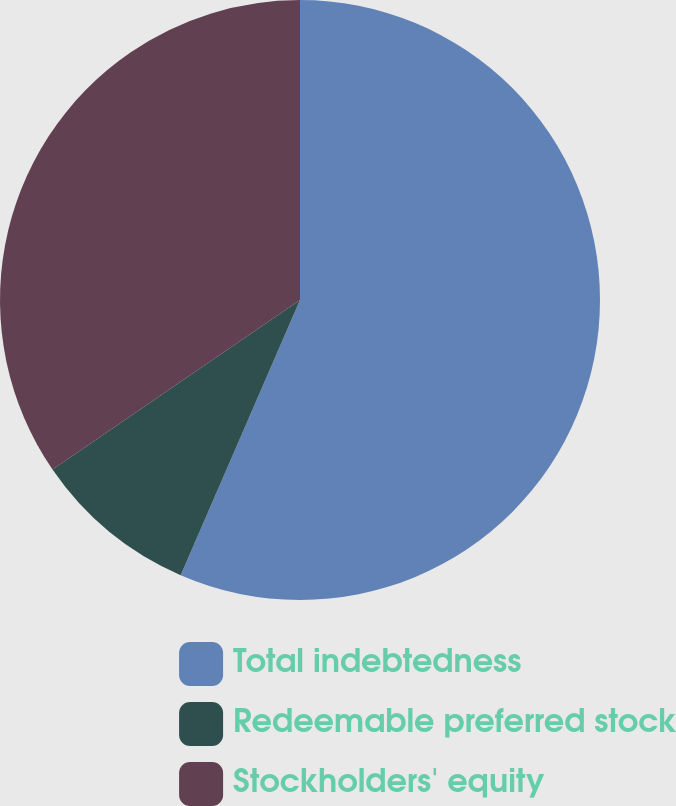<chart> <loc_0><loc_0><loc_500><loc_500><pie_chart><fcel>Total indebtedness<fcel>Redeemable preferred stock<fcel>Stockholders' equity<nl><fcel>56.51%<fcel>8.93%<fcel>34.56%<nl></chart> 